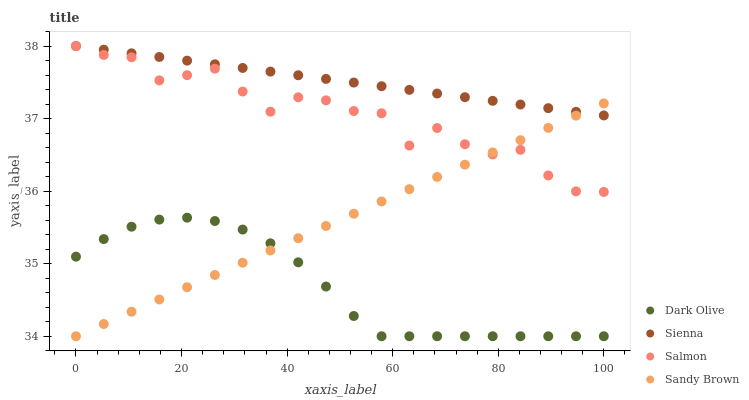Does Dark Olive have the minimum area under the curve?
Answer yes or no. Yes. Does Sienna have the maximum area under the curve?
Answer yes or no. Yes. Does Sandy Brown have the minimum area under the curve?
Answer yes or no. No. Does Sandy Brown have the maximum area under the curve?
Answer yes or no. No. Is Sienna the smoothest?
Answer yes or no. Yes. Is Salmon the roughest?
Answer yes or no. Yes. Is Sandy Brown the smoothest?
Answer yes or no. No. Is Sandy Brown the roughest?
Answer yes or no. No. Does Sandy Brown have the lowest value?
Answer yes or no. Yes. Does Salmon have the lowest value?
Answer yes or no. No. Does Salmon have the highest value?
Answer yes or no. Yes. Does Sandy Brown have the highest value?
Answer yes or no. No. Is Dark Olive less than Sienna?
Answer yes or no. Yes. Is Sienna greater than Dark Olive?
Answer yes or no. Yes. Does Sandy Brown intersect Salmon?
Answer yes or no. Yes. Is Sandy Brown less than Salmon?
Answer yes or no. No. Is Sandy Brown greater than Salmon?
Answer yes or no. No. Does Dark Olive intersect Sienna?
Answer yes or no. No. 